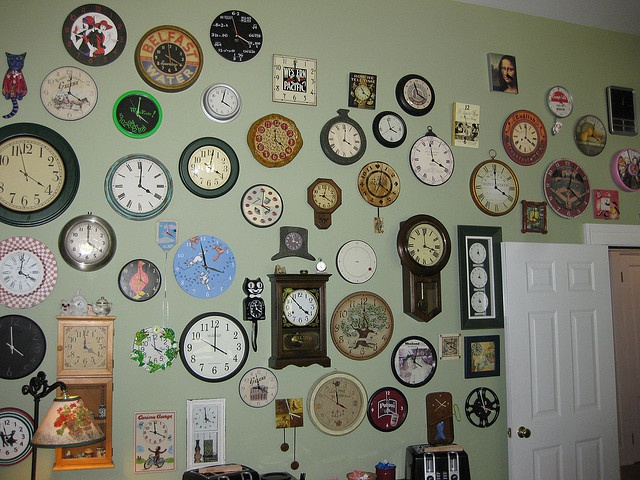Describe the objects in this image and their specific colors. I can see clock in gray, darkgray, lightgray, and black tones, clock in gray, black, tan, and darkgray tones, clock in gray, lightgray, and darkgray tones, clock in gray, black, darkgray, and maroon tones, and clock in gray, beige, and black tones in this image. 